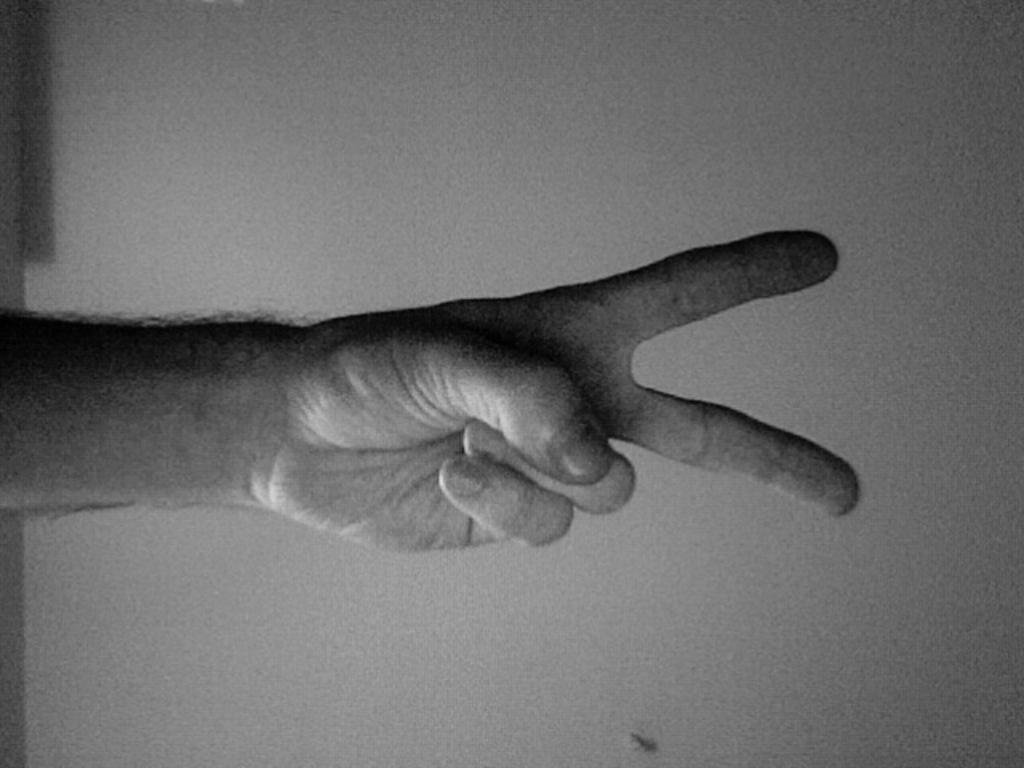What part of a person can be seen in the image? There is a person's hand in the image. What type of structure is visible in the image? There is a wall in the image. What color mode is the image in? The image is in black and white mode. Can you see a kitten sneezing in the image? There is no kitten or sneezing present in the image; it only features a person's hand and a wall in black and white mode. 